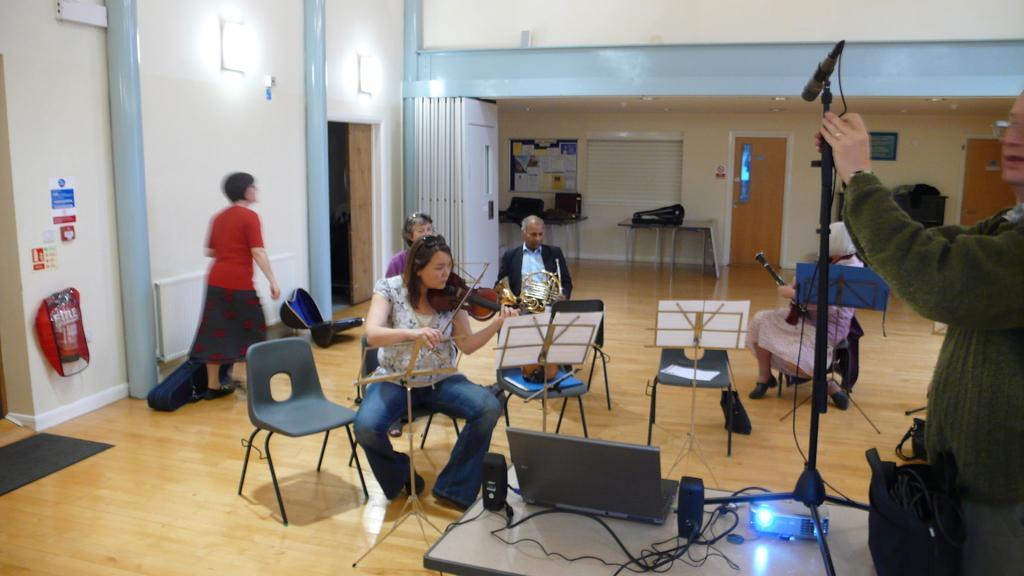How would you summarize this image in a sentence or two? In this picture there is a woman sitting on the chair playing piano. There is a paper and stand. There is a man and women who are sitting on the chair. There is a person holding a mic. There is a woman standing. There are two guitar boxes on the floor. There is a doormat, rad object. There is a table. There is a board and many papers on it. There is a door. 